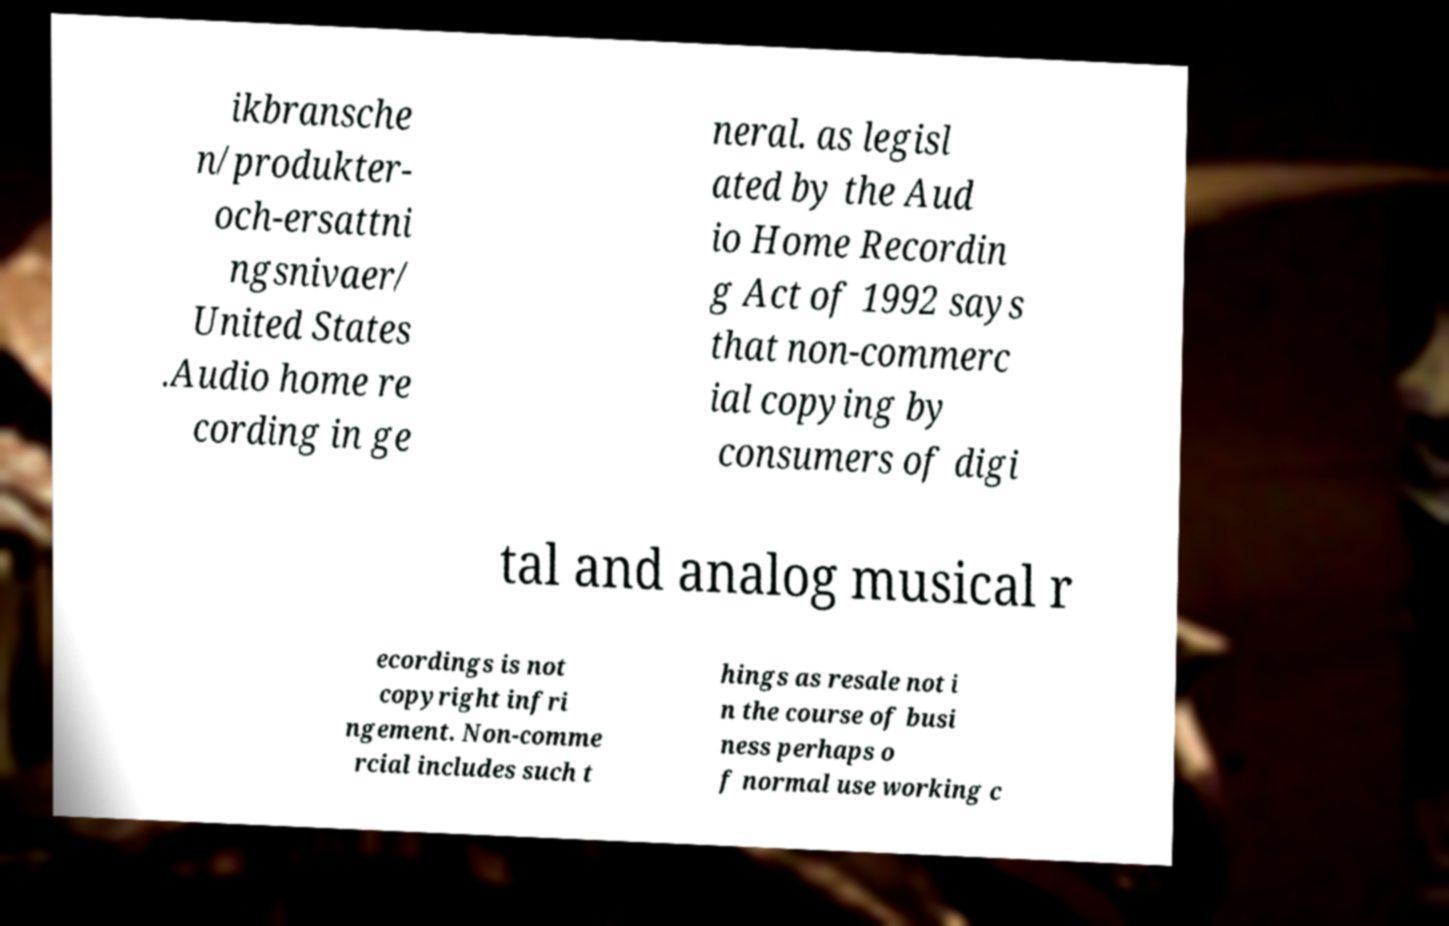What messages or text are displayed in this image? I need them in a readable, typed format. ikbransche n/produkter- och-ersattni ngsnivaer/ United States .Audio home re cording in ge neral. as legisl ated by the Aud io Home Recordin g Act of 1992 says that non-commerc ial copying by consumers of digi tal and analog musical r ecordings is not copyright infri ngement. Non-comme rcial includes such t hings as resale not i n the course of busi ness perhaps o f normal use working c 